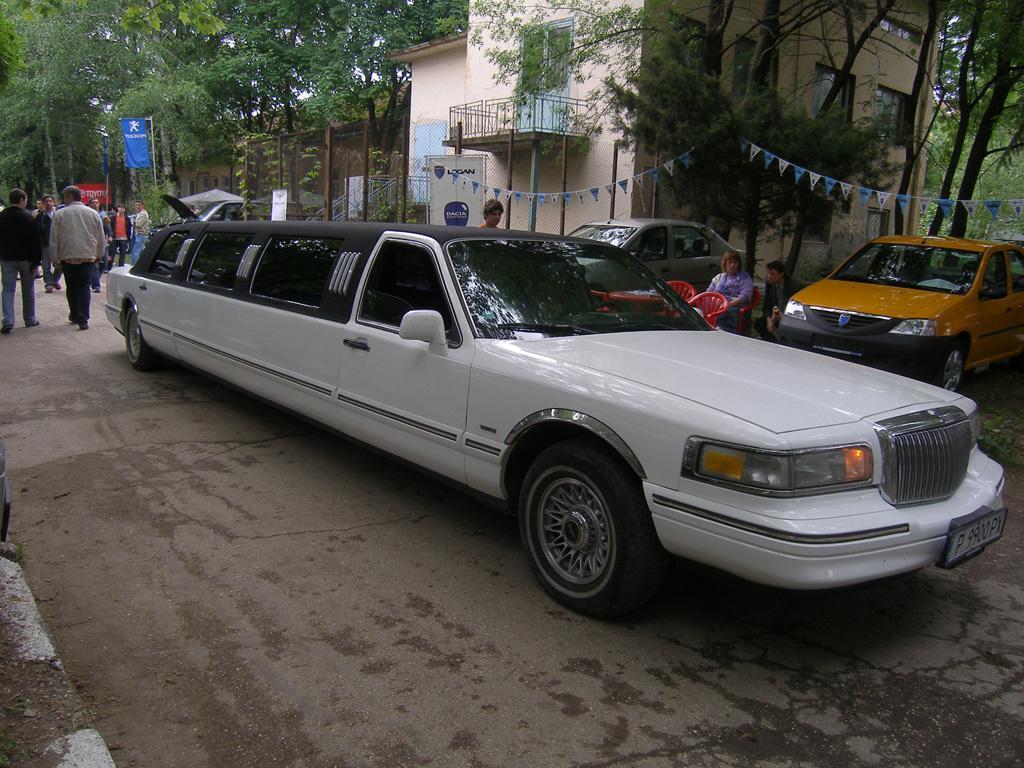How would you summarize this image in a sentence or two? In this image there are cars on a road, in the background there is a house, trees and people and a woman sitting on a chair. 